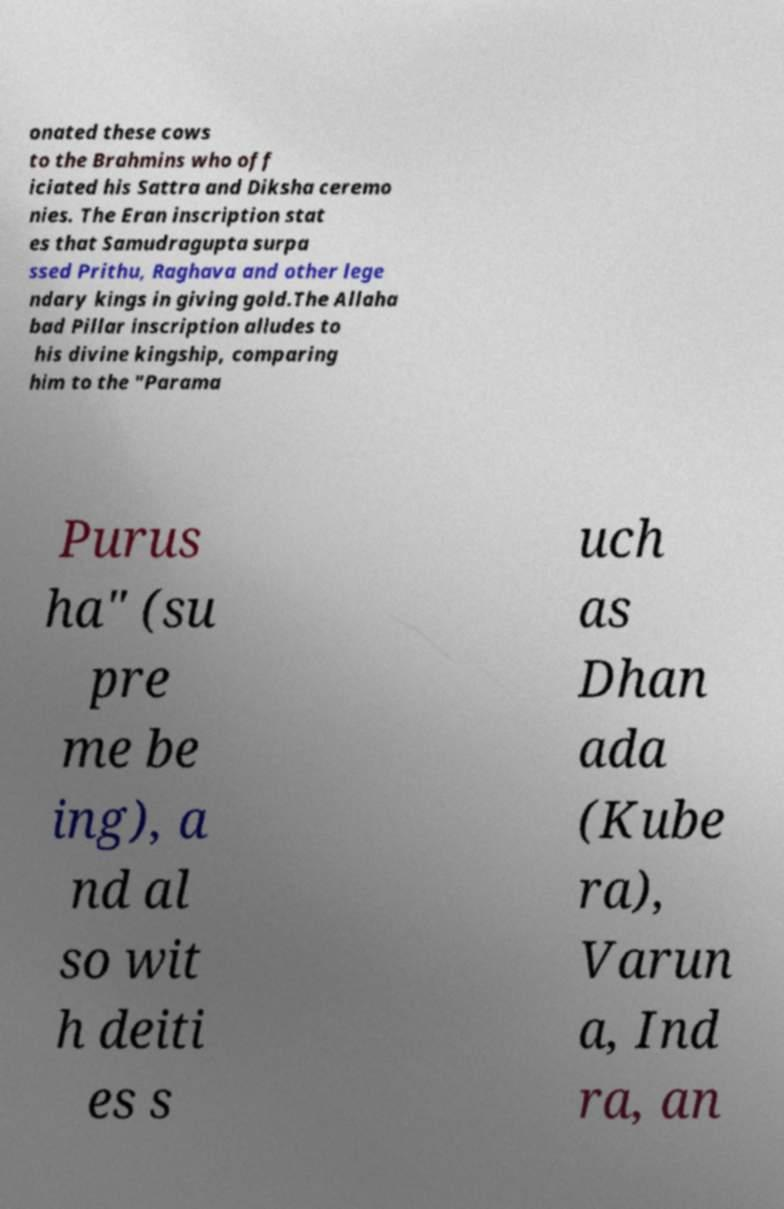Please identify and transcribe the text found in this image. onated these cows to the Brahmins who off iciated his Sattra and Diksha ceremo nies. The Eran inscription stat es that Samudragupta surpa ssed Prithu, Raghava and other lege ndary kings in giving gold.The Allaha bad Pillar inscription alludes to his divine kingship, comparing him to the "Parama Purus ha" (su pre me be ing), a nd al so wit h deiti es s uch as Dhan ada (Kube ra), Varun a, Ind ra, an 